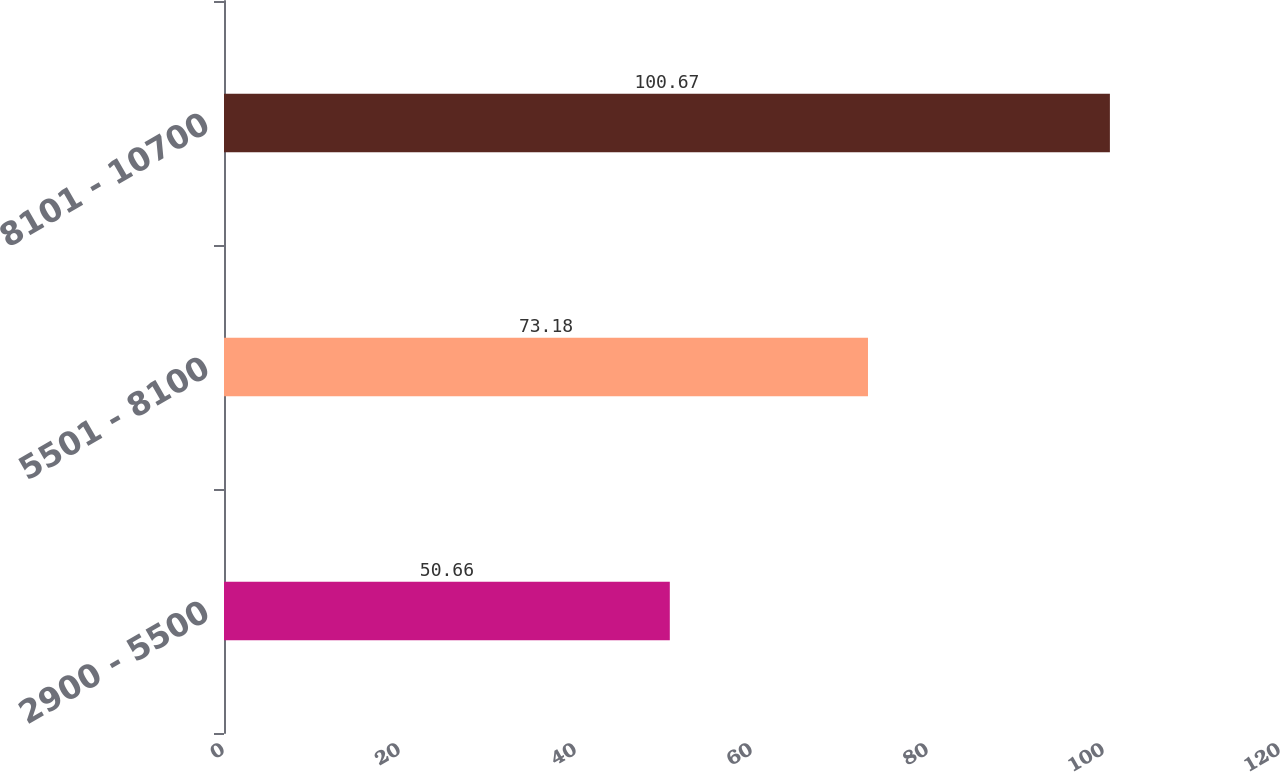<chart> <loc_0><loc_0><loc_500><loc_500><bar_chart><fcel>2900 - 5500<fcel>5501 - 8100<fcel>8101 - 10700<nl><fcel>50.66<fcel>73.18<fcel>100.67<nl></chart> 